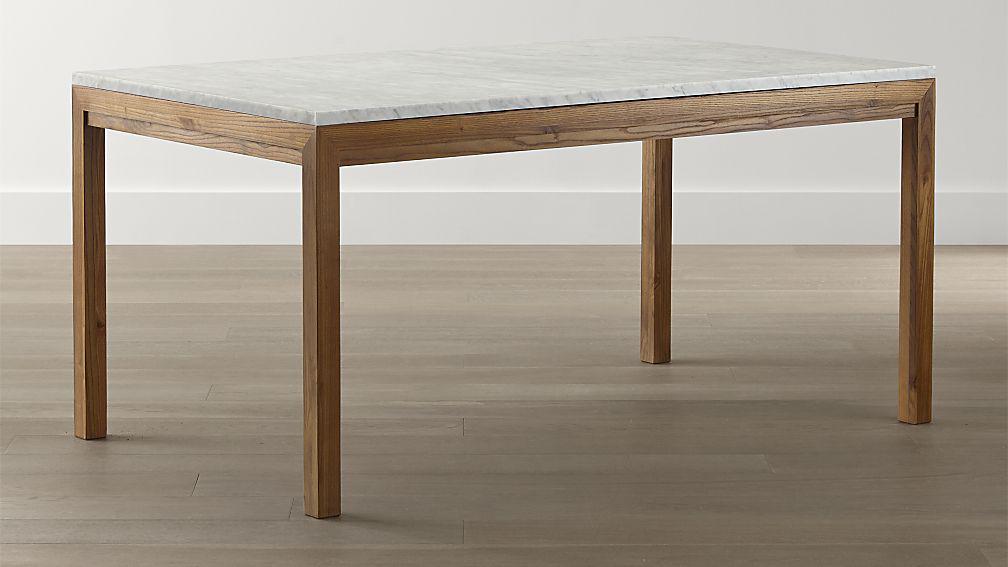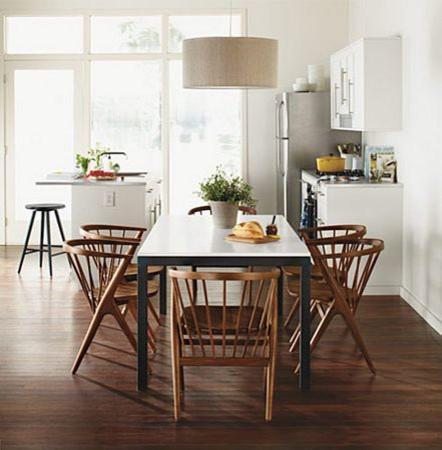The first image is the image on the left, the second image is the image on the right. For the images shown, is this caption "At least one image shows a rectangular dining table with chairs on each side and each end." true? Answer yes or no. Yes. The first image is the image on the left, the second image is the image on the right. Evaluate the accuracy of this statement regarding the images: "there are exactly two chairs in the image on the right". Is it true? Answer yes or no. No. 